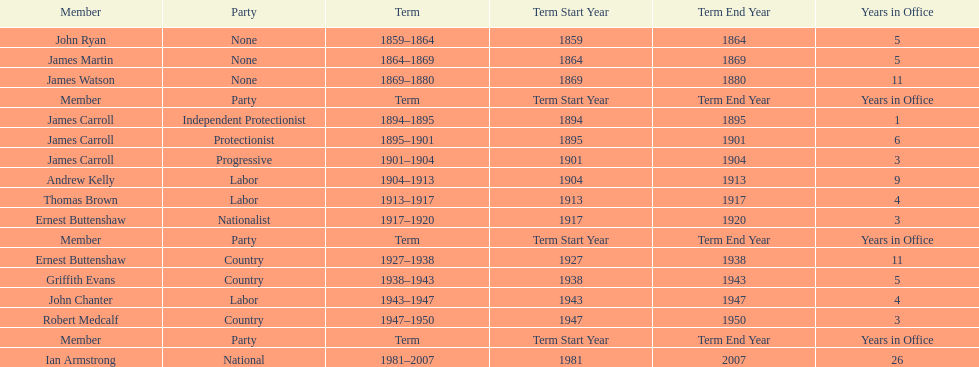Which member of the second incarnation of the lachlan was also a nationalist? Ernest Buttenshaw. 